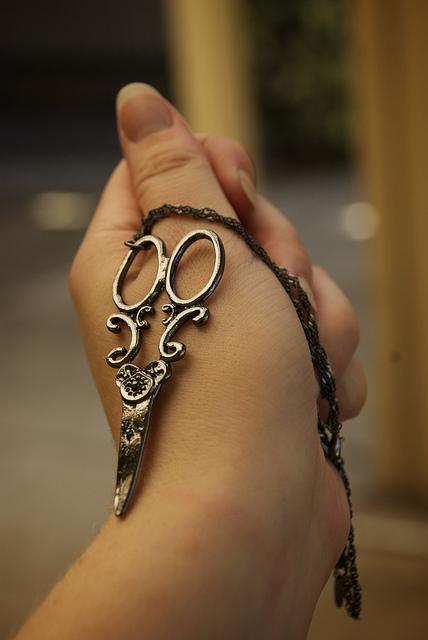What is in the person's hand?
Quick response, please. Scissors. What gender is the person being photographed?
Keep it brief. Female. Which hand is holding the scissors?
Be succinct. Left. What color is the chain she is holding?
Concise answer only. Brown. What is this person holding?
Be succinct. Scissors. Is the person male or female?
Write a very short answer. Female. 